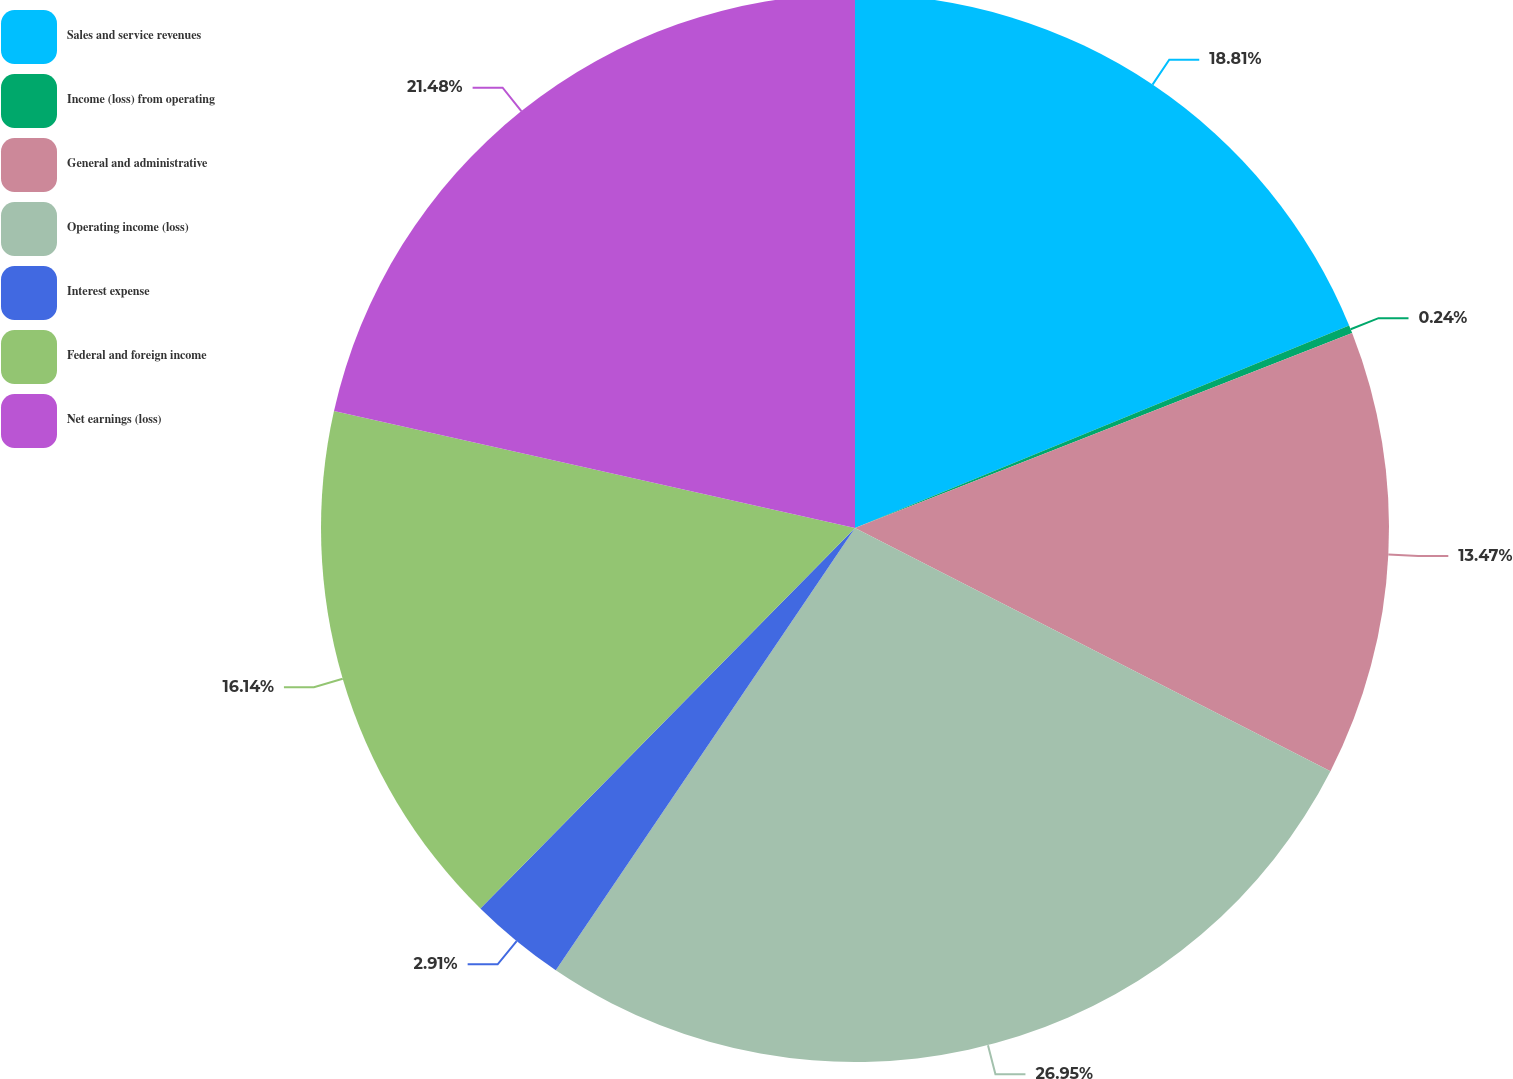<chart> <loc_0><loc_0><loc_500><loc_500><pie_chart><fcel>Sales and service revenues<fcel>Income (loss) from operating<fcel>General and administrative<fcel>Operating income (loss)<fcel>Interest expense<fcel>Federal and foreign income<fcel>Net earnings (loss)<nl><fcel>18.81%<fcel>0.24%<fcel>13.47%<fcel>26.94%<fcel>2.91%<fcel>16.14%<fcel>21.48%<nl></chart> 